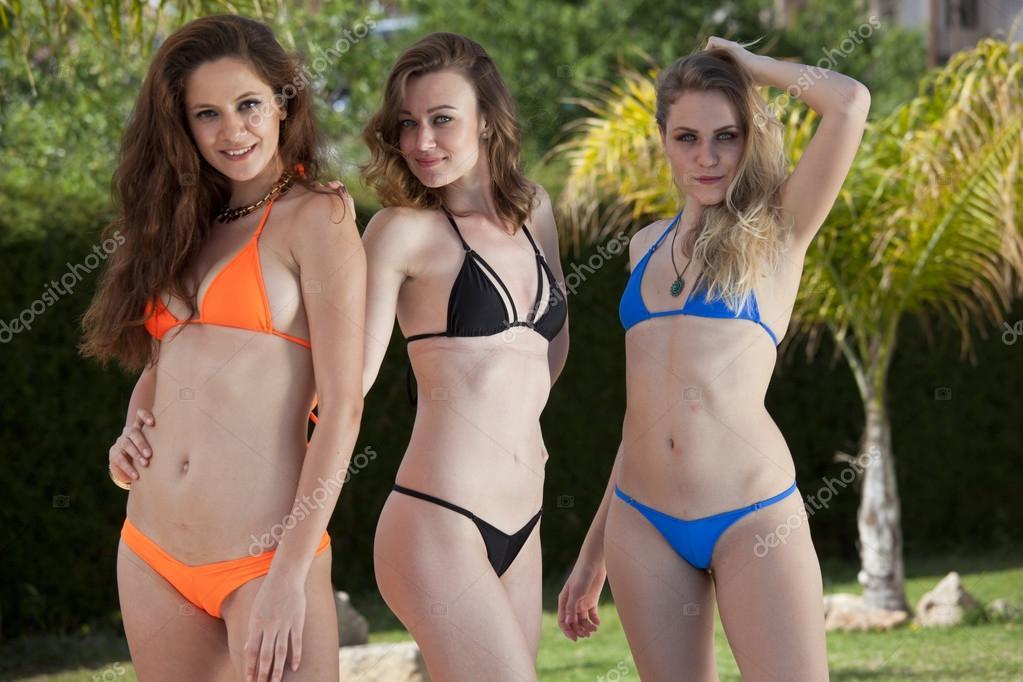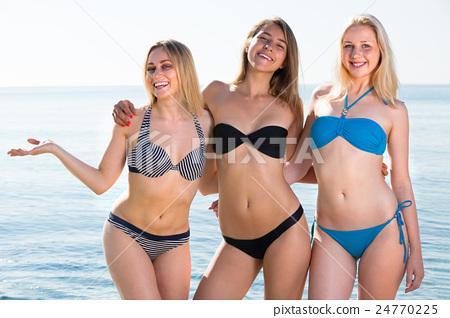The first image is the image on the left, the second image is the image on the right. For the images displayed, is the sentence "An image shows three standing models, each wearing a different solid-colored bikini with matching top and bottom." factually correct? Answer yes or no. Yes. The first image is the image on the left, the second image is the image on the right. Analyze the images presented: Is the assertion "Three women are standing on the shore in the image on the left." valid? Answer yes or no. No. 